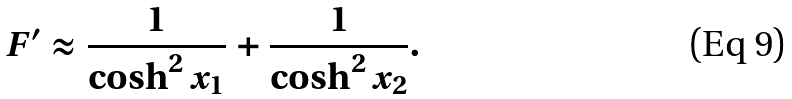<formula> <loc_0><loc_0><loc_500><loc_500>F ^ { \prime } \approx \frac { 1 } { \cosh ^ { 2 } x _ { 1 } } + \frac { 1 } { \cosh ^ { 2 } x _ { 2 } } .</formula> 